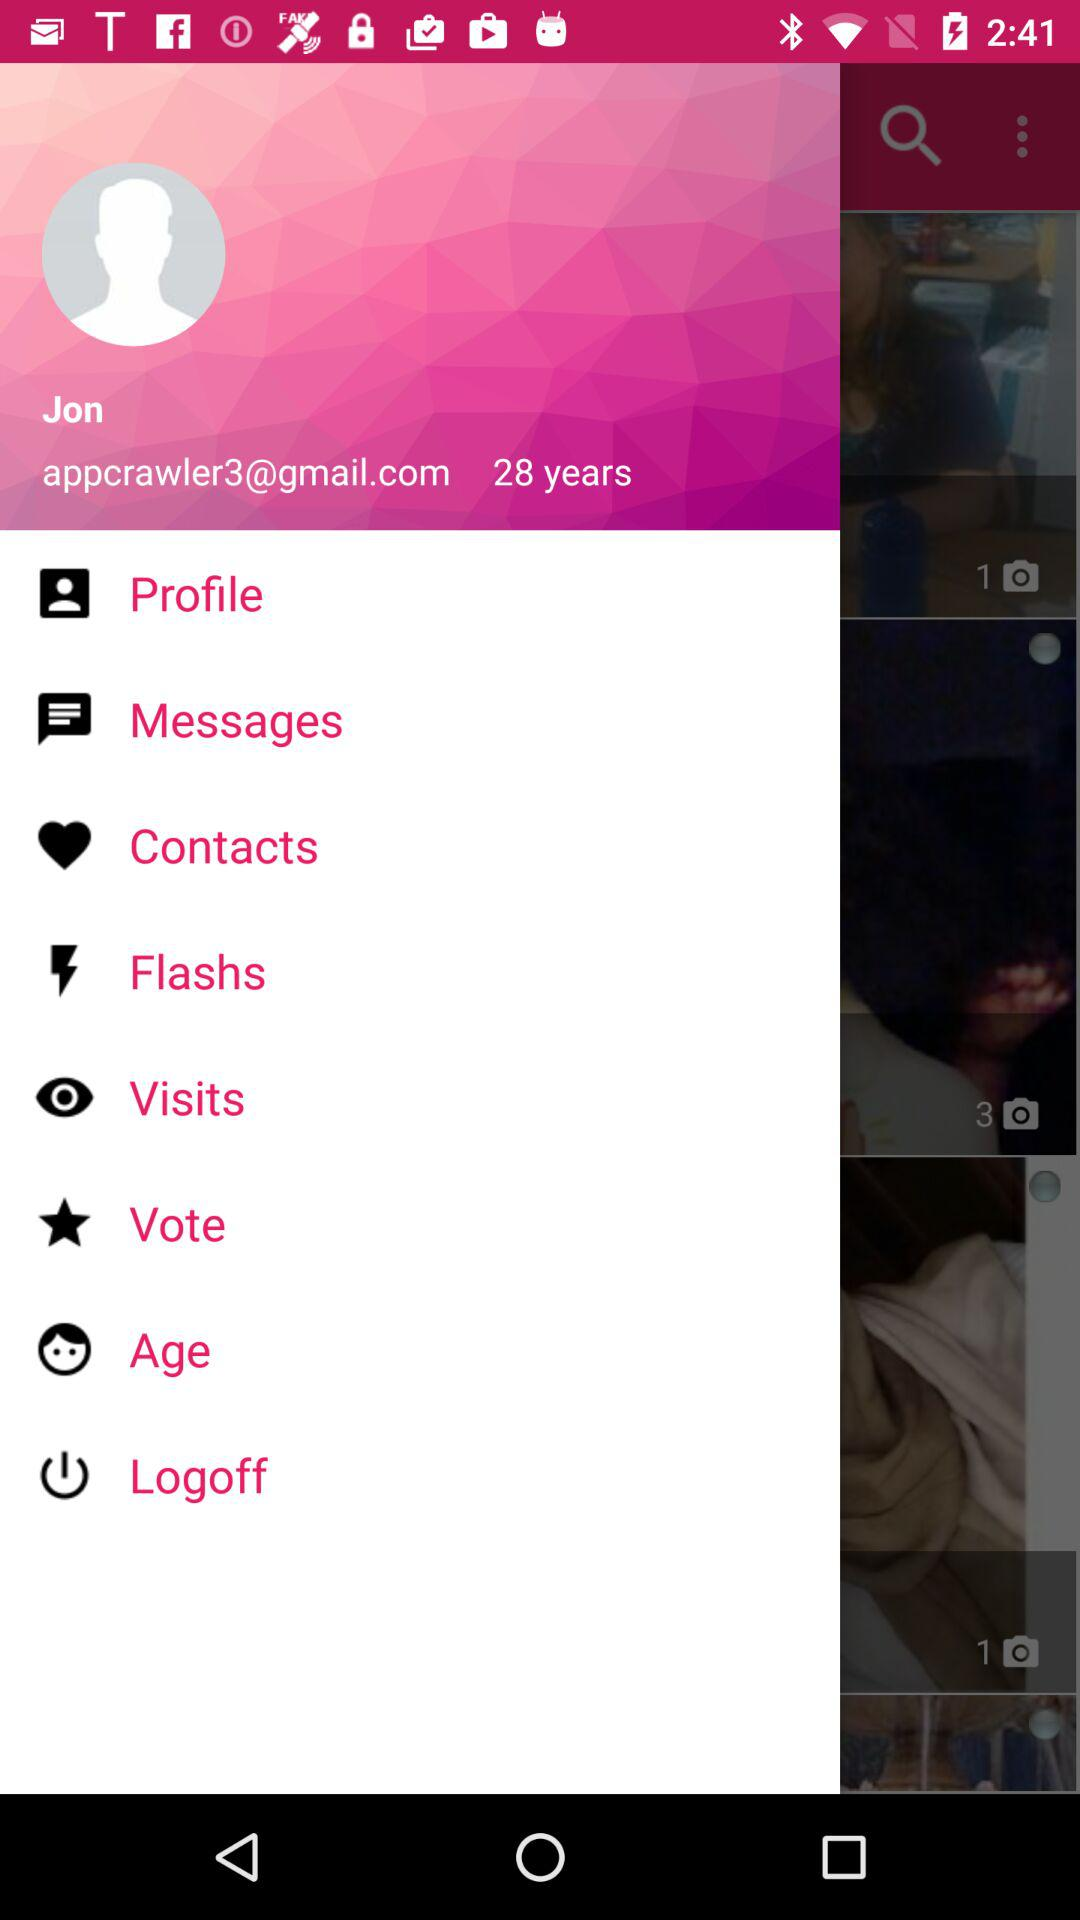What is the email address? The email address is appcrawler3@gmail.com. 